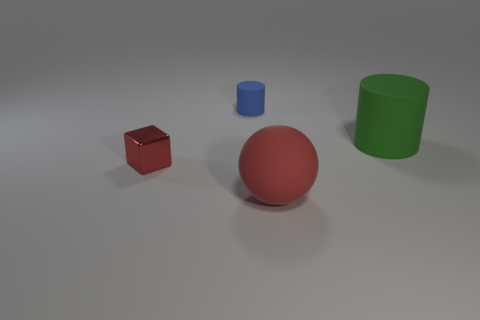What material is the big object that is the same shape as the small matte object?
Offer a very short reply. Rubber. How big is the red thing that is to the right of the red thing left of the big matte thing that is in front of the large green object?
Provide a short and direct response. Large. Are there any big green cylinders in front of the big matte ball?
Your answer should be very brief. No. There is a red ball that is the same material as the large cylinder; what size is it?
Your answer should be very brief. Large. How many other tiny matte objects are the same shape as the green object?
Your answer should be very brief. 1. Are the large green cylinder and the tiny object that is right of the tiny red shiny cube made of the same material?
Provide a short and direct response. Yes. Is the number of tiny matte objects on the right side of the rubber sphere greater than the number of green matte cylinders?
Provide a succinct answer. No. The big matte object that is the same color as the metallic cube is what shape?
Make the answer very short. Sphere. Is there a large cylinder made of the same material as the tiny red block?
Ensure brevity in your answer.  No. Do the object on the right side of the sphere and the big object in front of the green rubber object have the same material?
Make the answer very short. Yes. 